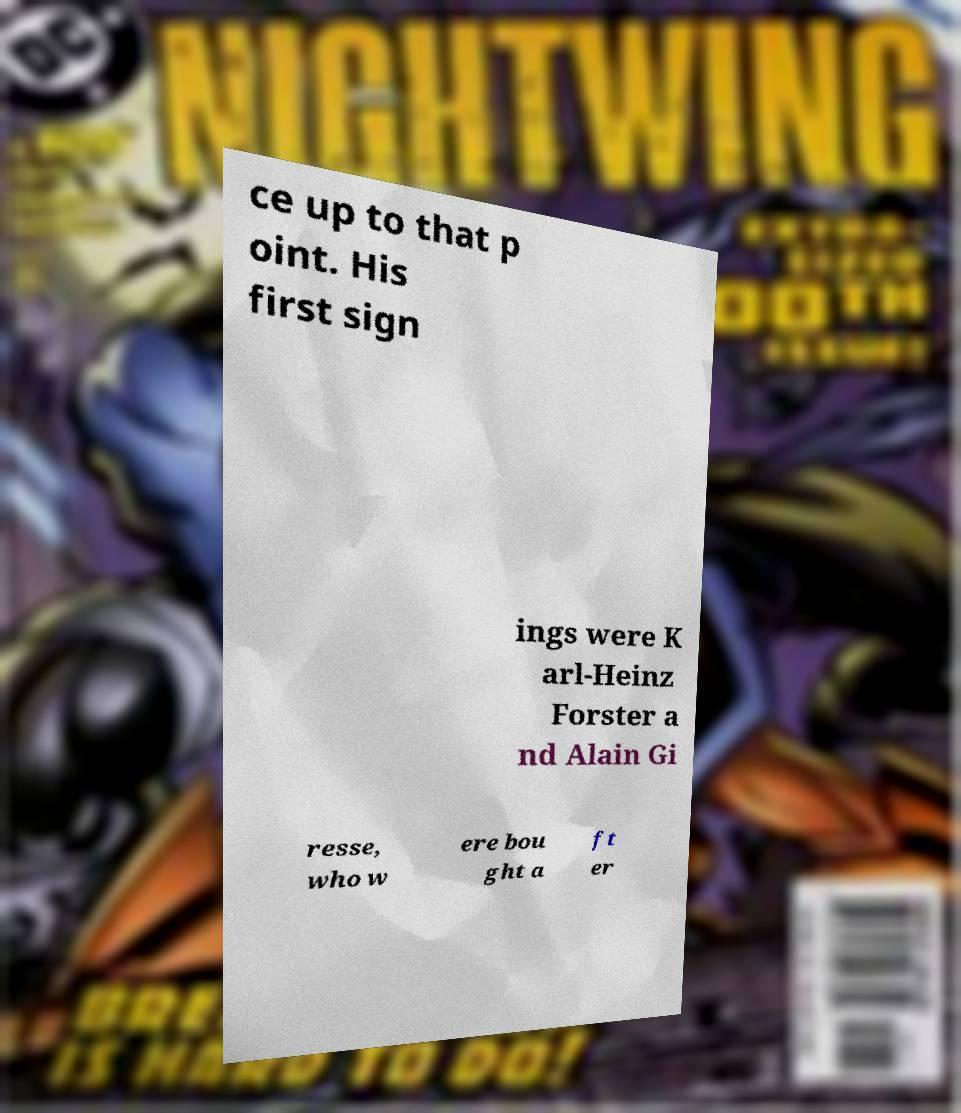Can you read and provide the text displayed in the image?This photo seems to have some interesting text. Can you extract and type it out for me? ce up to that p oint. His first sign ings were K arl-Heinz Forster a nd Alain Gi resse, who w ere bou ght a ft er 